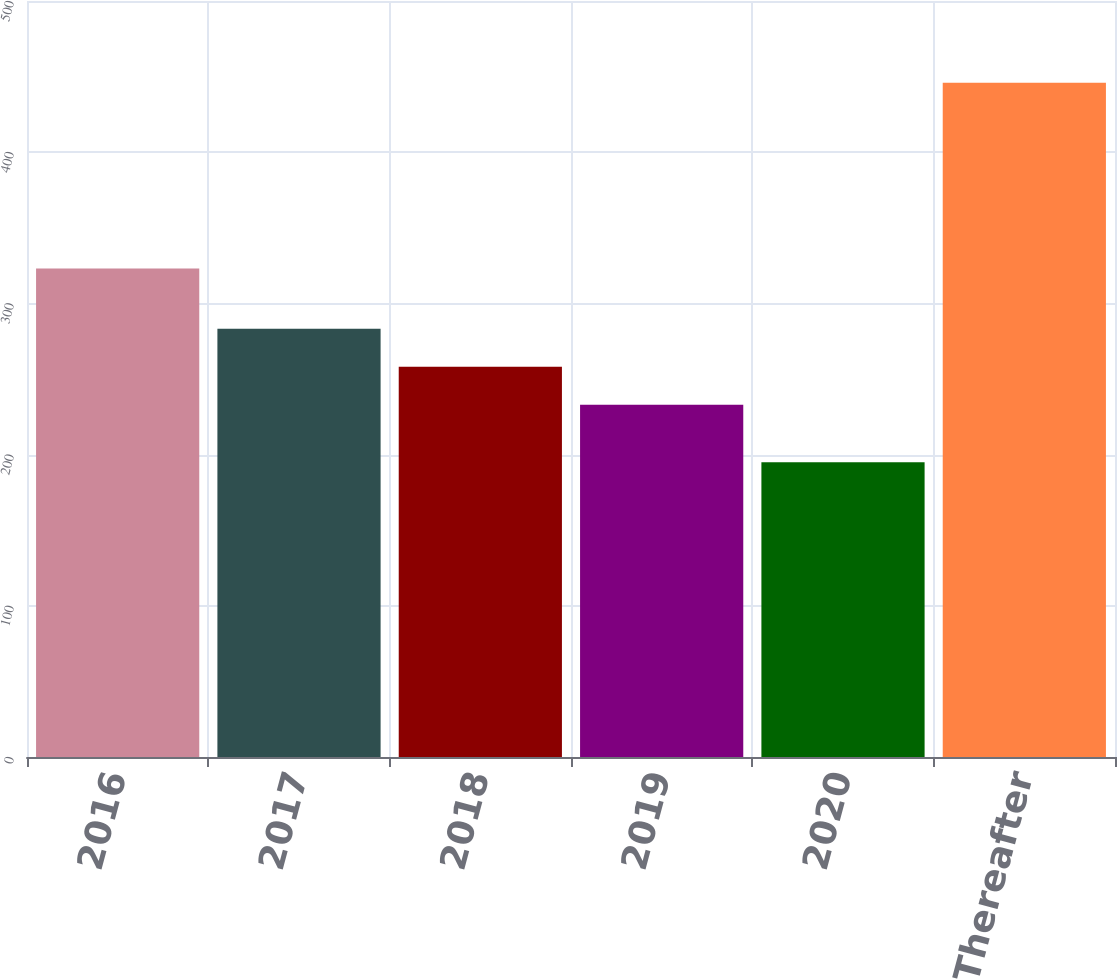<chart> <loc_0><loc_0><loc_500><loc_500><bar_chart><fcel>2016<fcel>2017<fcel>2018<fcel>2019<fcel>2020<fcel>Thereafter<nl><fcel>323<fcel>283.2<fcel>258.1<fcel>233<fcel>195<fcel>446<nl></chart> 